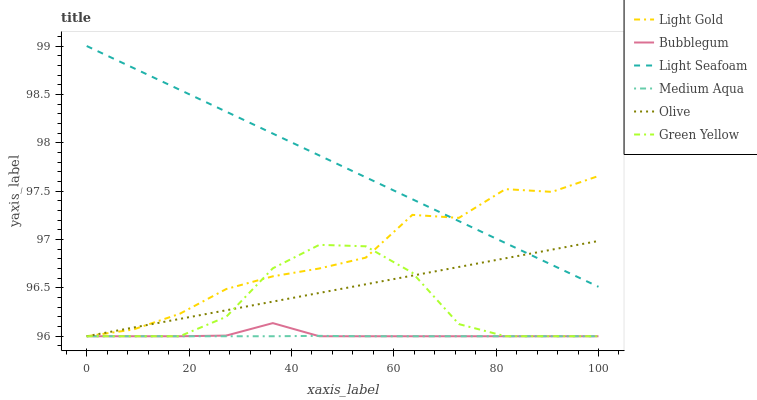Does Bubblegum have the minimum area under the curve?
Answer yes or no. No. Does Bubblegum have the maximum area under the curve?
Answer yes or no. No. Is Bubblegum the smoothest?
Answer yes or no. No. Is Bubblegum the roughest?
Answer yes or no. No. Does Bubblegum have the highest value?
Answer yes or no. No. Is Bubblegum less than Light Seafoam?
Answer yes or no. Yes. Is Light Seafoam greater than Green Yellow?
Answer yes or no. Yes. Does Bubblegum intersect Light Seafoam?
Answer yes or no. No. 